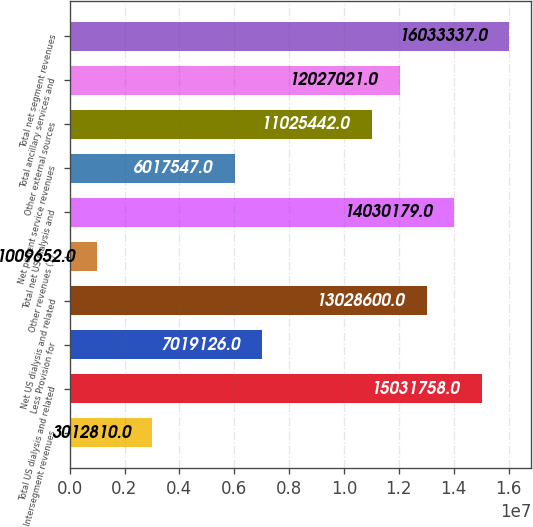Convert chart. <chart><loc_0><loc_0><loc_500><loc_500><bar_chart><fcel>Intersegment revenues<fcel>Total US dialysis and related<fcel>Less Provision for<fcel>Net US dialysis and related<fcel>Other revenues (1)<fcel>Total net US dialysis and<fcel>Net patient service revenues<fcel>Other external sources<fcel>Total ancillary services and<fcel>Total net segment revenues<nl><fcel>3.01281e+06<fcel>1.50318e+07<fcel>7.01913e+06<fcel>1.30286e+07<fcel>1.00965e+06<fcel>1.40302e+07<fcel>6.01755e+06<fcel>1.10254e+07<fcel>1.2027e+07<fcel>1.60333e+07<nl></chart> 